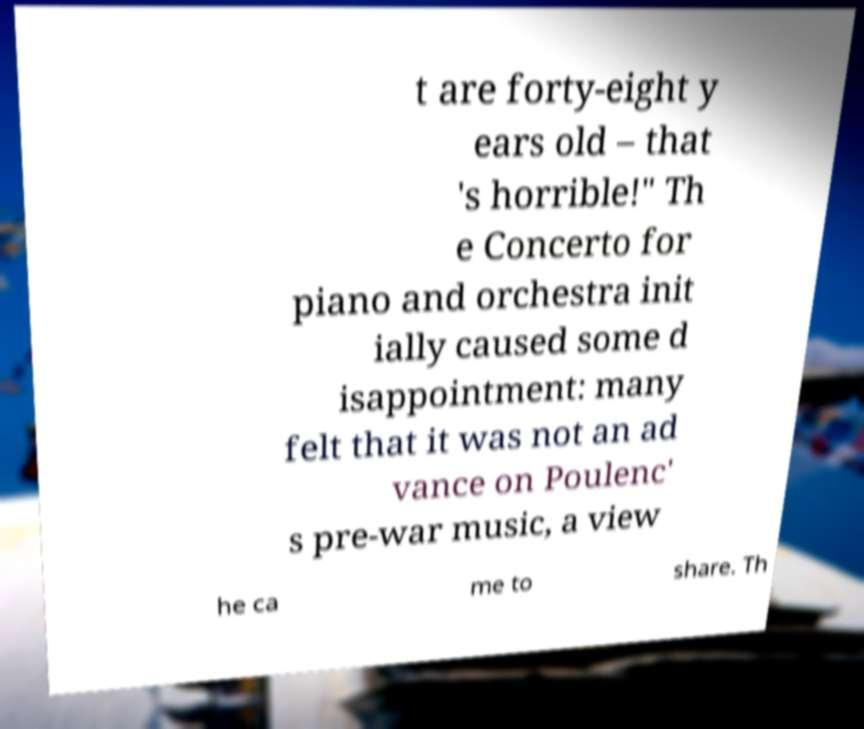For documentation purposes, I need the text within this image transcribed. Could you provide that? t are forty-eight y ears old – that 's horrible!" Th e Concerto for piano and orchestra init ially caused some d isappointment: many felt that it was not an ad vance on Poulenc' s pre-war music, a view he ca me to share. Th 